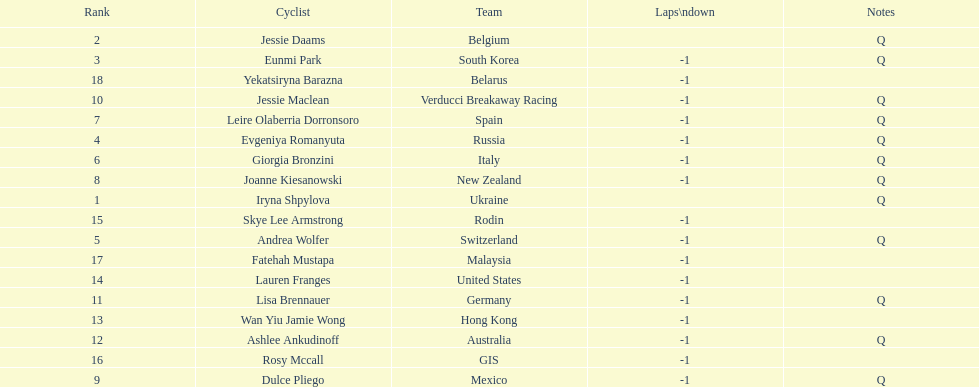What is the number rank of belgium? 2. Could you parse the entire table? {'header': ['Rank', 'Cyclist', 'Team', 'Laps\\ndown', 'Notes'], 'rows': [['2', 'Jessie Daams', 'Belgium', '', 'Q'], ['3', 'Eunmi Park', 'South Korea', '-1', 'Q'], ['18', 'Yekatsiryna Barazna', 'Belarus', '-1', ''], ['10', 'Jessie Maclean', 'Verducci Breakaway Racing', '-1', 'Q'], ['7', 'Leire Olaberria Dorronsoro', 'Spain', '-1', 'Q'], ['4', 'Evgeniya Romanyuta', 'Russia', '-1', 'Q'], ['6', 'Giorgia Bronzini', 'Italy', '-1', 'Q'], ['8', 'Joanne Kiesanowski', 'New Zealand', '-1', 'Q'], ['1', 'Iryna Shpylova', 'Ukraine', '', 'Q'], ['15', 'Skye Lee Armstrong', 'Rodin', '-1', ''], ['5', 'Andrea Wolfer', 'Switzerland', '-1', 'Q'], ['17', 'Fatehah Mustapa', 'Malaysia', '-1', ''], ['14', 'Lauren Franges', 'United States', '-1', ''], ['11', 'Lisa Brennauer', 'Germany', '-1', 'Q'], ['13', 'Wan Yiu Jamie Wong', 'Hong Kong', '-1', ''], ['12', 'Ashlee Ankudinoff', 'Australia', '-1', 'Q'], ['16', 'Rosy Mccall', 'GIS', '-1', ''], ['9', 'Dulce Pliego', 'Mexico', '-1', 'Q']]} 